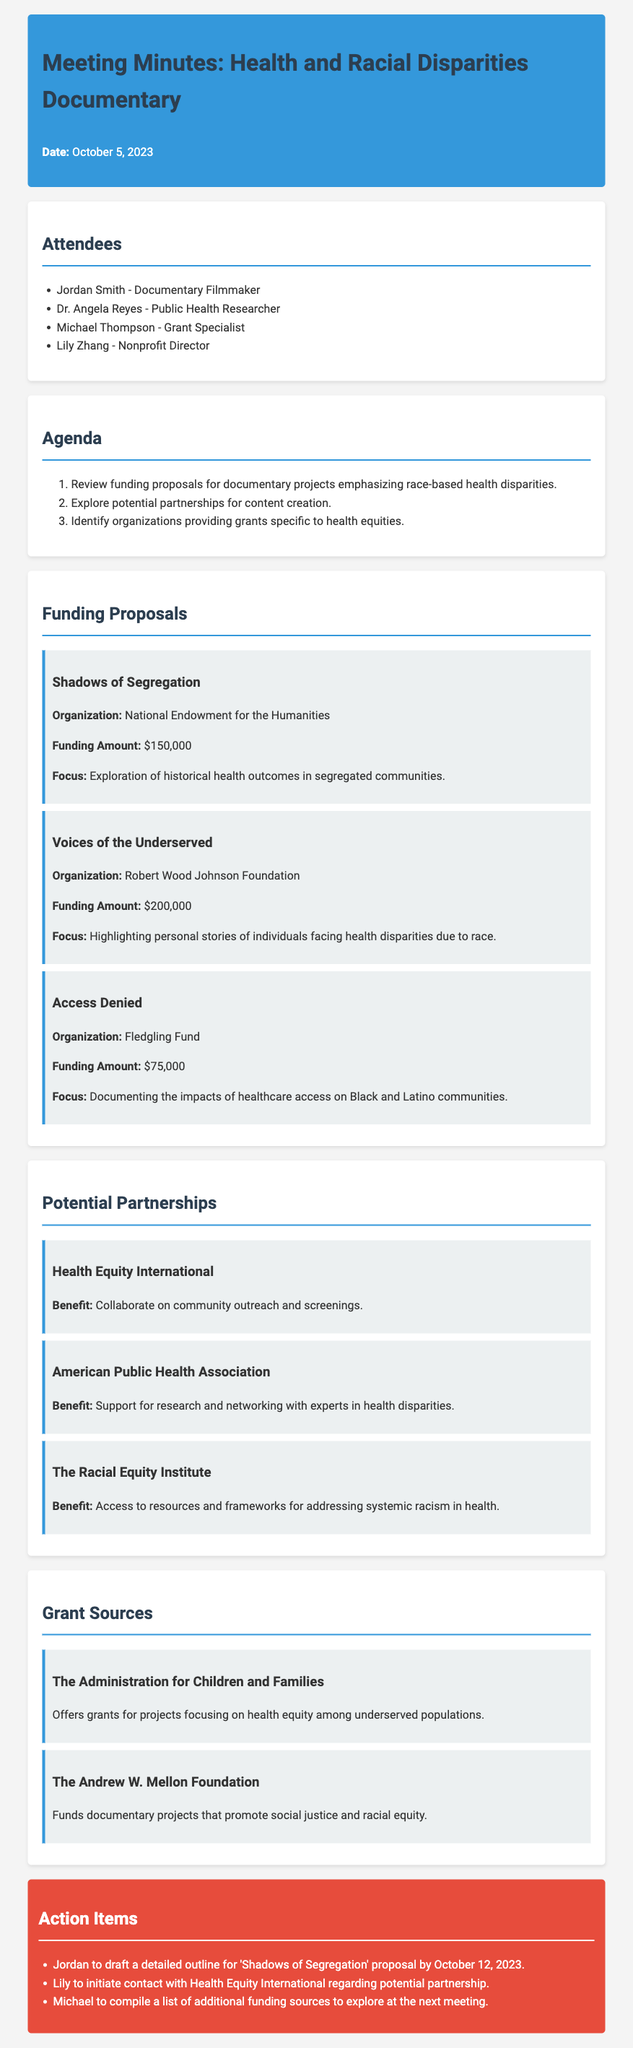What is the date of the meeting? The date of the meeting is stated at the top of the document.
Answer: October 5, 2023 Who is the grant specialist attending the meeting? The name of the grant specialist is listed under attendees.
Answer: Michael Thompson What is the funding amount for the project "Voices of the Underserved"? The funding amount is mentioned in the funding proposals section for this specific project.
Answer: $200,000 What organization is associated with "Access Denied"? The organization is provided in the details for this funding proposal in the document.
Answer: Fledgling Fund Which potential partner is focused on addressing systemic racism in health? This detail is found under the potential partnerships section and identifies the organization involved in this work.
Answer: The Racial Equity Institute How many documentary project proposals were reviewed? The number of proposals can be counted from the funding proposals section.
Answer: 3 What is one proposed action item for Jordan? The action items list specifies what Jordan needs to do next in relation to the proposals discussed.
Answer: Draft a detailed outline for 'Shadows of Segregation' proposal by October 12, 2023 What foundation funds documentary projects that promote social justice? The document lists foundations that provide funding, specifying one that supports social justice initiatives.
Answer: The Andrew W. Mellon Foundation What is the focus of the project "Shadows of Segregation"? The focus of the project is summarized in its funding proposal section.
Answer: Exploration of historical health outcomes in segregated communities 